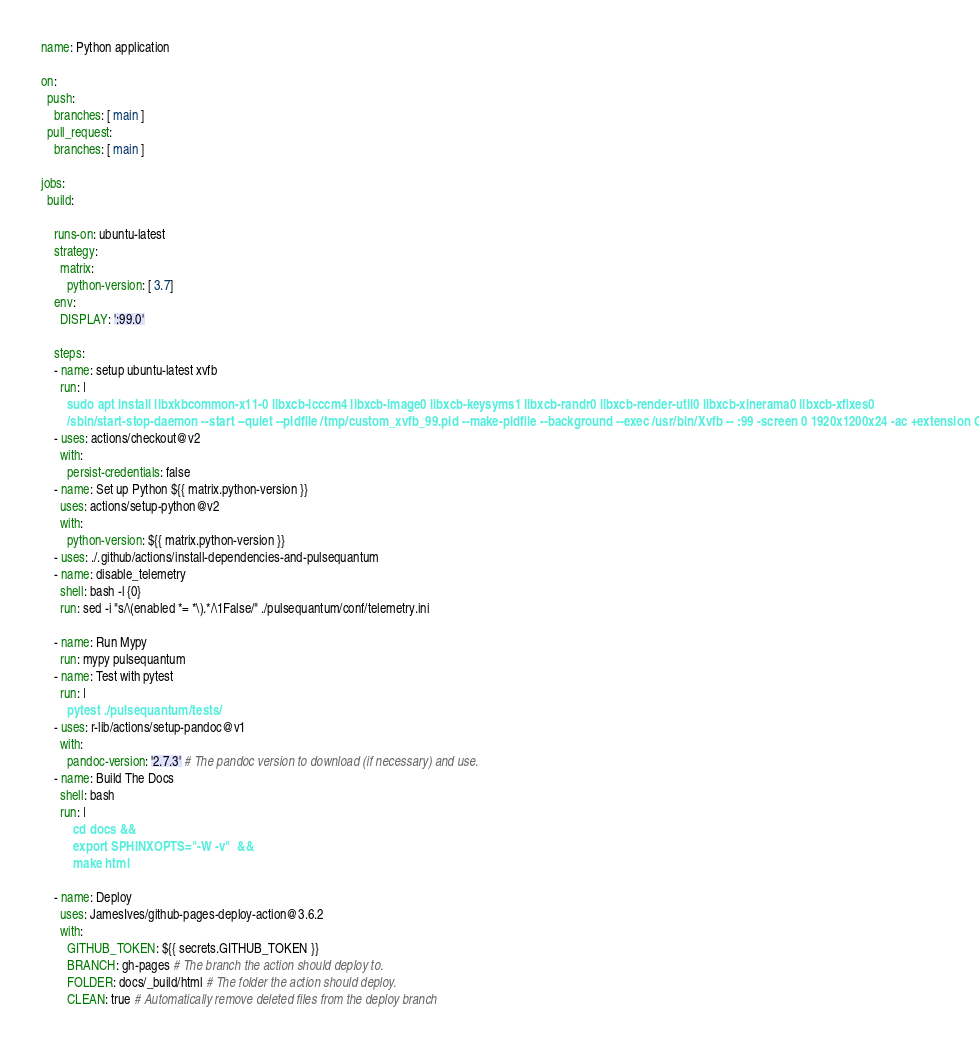Convert code to text. <code><loc_0><loc_0><loc_500><loc_500><_YAML_>name: Python application

on:
  push:
    branches: [ main ]
  pull_request:
    branches: [ main ]

jobs:
  build:

    runs-on: ubuntu-latest
    strategy:
      matrix:
        python-version: [ 3.7]
    env:
      DISPLAY: ':99.0'

    steps:
    - name: setup ubuntu-latest xvfb
      run: |
        sudo apt install libxkbcommon-x11-0 libxcb-icccm4 libxcb-image0 libxcb-keysyms1 libxcb-randr0 libxcb-render-util0 libxcb-xinerama0 libxcb-xfixes0
        /sbin/start-stop-daemon --start --quiet --pidfile /tmp/custom_xvfb_99.pid --make-pidfile --background --exec /usr/bin/Xvfb -- :99 -screen 0 1920x1200x24 -ac +extension GLX
    - uses: actions/checkout@v2
      with:
        persist-credentials: false
    - name: Set up Python ${{ matrix.python-version }}
      uses: actions/setup-python@v2
      with:
        python-version: ${{ matrix.python-version }}
    - uses: ./.github/actions/install-dependencies-and-pulsequantum
    - name: disable_telemetry
      shell: bash -l {0}
      run: sed -i "s/\(enabled *= *\).*/\1False/" ./pulsequantum/conf/telemetry.ini

    - name: Run Mypy
      run: mypy pulsequantum
    - name: Test with pytest
      run: |
        pytest ./pulsequantum/tests/
    - uses: r-lib/actions/setup-pandoc@v1
      with:
        pandoc-version: '2.7.3' # The pandoc version to download (if necessary) and use.
    - name: Build The Docs 
      shell: bash  
      run: |
          cd docs &&
          export SPHINXOPTS="-W -v"  &&
          make html
          
    - name: Deploy
      uses: JamesIves/github-pages-deploy-action@3.6.2
      with:
        GITHUB_TOKEN: ${{ secrets.GITHUB_TOKEN }}
        BRANCH: gh-pages # The branch the action should deploy to.
        FOLDER: docs/_build/html # The folder the action should deploy.
        CLEAN: true # Automatically remove deleted files from the deploy branch


</code> 